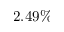<formula> <loc_0><loc_0><loc_500><loc_500>2 . 4 9 \%</formula> 